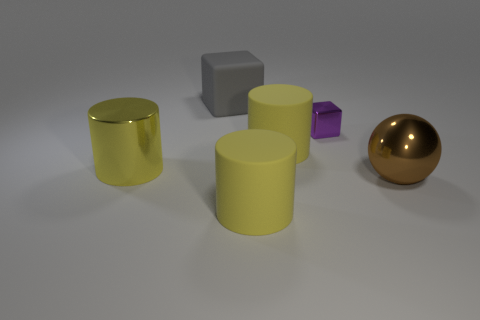How do the objects differ in terms of color? The objects in the image display a variety of colors. From left to right, the first cylinder has a reflective gold finish, the next two cylinders are matte and colored yellow. The small cube is purple, exhibiting a slightly shiny surface, and the larger cube is a gray color with a dull matte finish. Finally, the sphere has a rich, reflective gold hue, adding a touch of elegance to the scene. Do the colors of these objects signify anything? In this image, the colors don't appear to signify anything specific. They could simply be chosen for their aesthetic appeal or to demonstrate the rendering capabilities of different surface materials and colors in a 3D modeling program. 